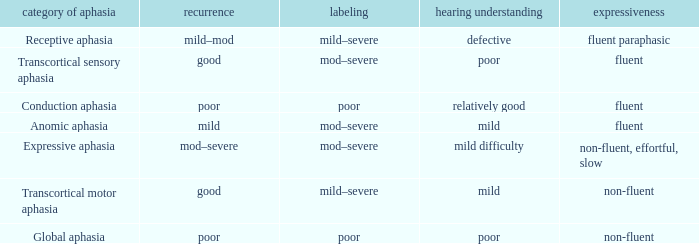Name the number of naming for anomic aphasia 1.0. 